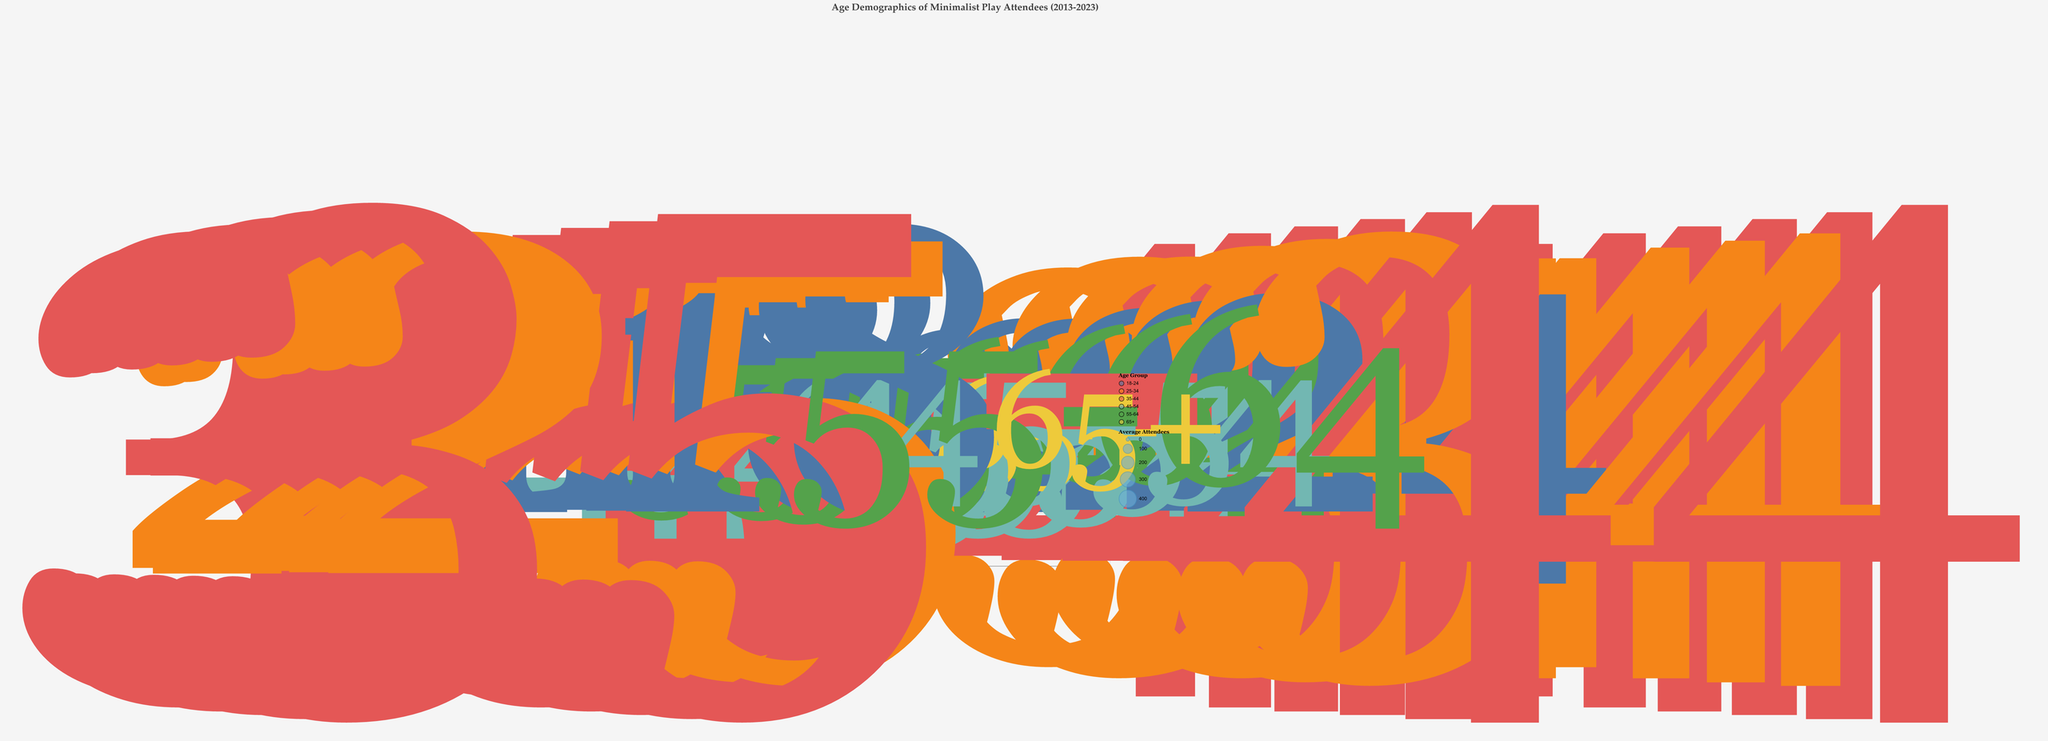What is the title of the chart? The title is displayed at the top of the chart in a larger font. The title reads, "Age Demographics of Minimalist Play Attendees (2013-2023)"
Answer: Age Demographics of Minimalist Play Attendees (2013-2023) What are the years represented on the x-axis? The x-axis marks the years, clearly visible along the horizontal axis. The years represented range from 2013 to 2023, with markers for individual years in-between.
Answer: 2013 to 2023 Which age group had the highest average attendees in 2023? Each bubble's size represents the average attendees, and each bubble's color represents an age group. The largest bubble in 2023, color-coded for the 35-44 age group, indicates this group had the highest average attendees.
Answer: 35-44 How did the average rating for the 55-64 age group change between 2013 and 2023? By observing the vertical position of the bubbles for the 55-64 age group in the years 2013 and 2023, it is clear that the rating increased. In 2013, the rating was at 4.0, and by 2023 it had risen to 4.5.
Answer: Increased from 4.0 to 4.5 What is the difference in average attendees between the 18-24 and 65+ age groups in 2023? Referring to the size of the bubbles for the 18-24 age group (250 attendees) and the 65+ age group (75 attendees) in 2023, subtracting the average attendees for 65+ from 18-24 yields a difference of 175.
Answer: 175 Which age group shows the highest average rating across the entire dataset? By observing the y-axis, which represents the average rating, the highest point is 5.4. Checking the bubble at this point shows it belongs to the 35-44 age group in the year 2023.
Answer: 35-44 Which year had the largest range of average ratings based on the bubbles' vertical span? Comparing the vertical span of the bubbles across the years, 2023 shows the largest range of ratings. The lowest rating is for the 65+ group at 4.0 and the highest rating is for the 35-44 group at 5.4, making the range 1.4.
Answer: 2023 Between which years did the 25-34 age group's average rating increase the most? Tracking the upward movement of the bubbles color-coded for the 25-34 age group shows an increase from a rating of 4.9 in 2017 to 5.0 in 2019, 5.1 in 2021, and 5.2 in 2023. The largest single-step increase is from 2017 to 2019 by 0.1.
Answer: 2017 to 2019 How does the set complexity score relate to the audience size over the years? By examining the tooltips, the set complexity scores tend to stay relatively stable and low, varying slightly around 1.2 to 1.6, regardless of the average attendees sizes. This lacks a clear pattern, suggesting set complexity does not directly correlate with audience size.
Answer: No clear pattern How do the average ratings of the youngest and oldest age groups compare overall? Reviewing the bubble positions for the youngest (18-24) and oldest (65+) age groups shows that the youngest consistently score higher over the years. For instance, the youngest range from 4.5 to 5.0, while the oldest range from 3.7 to 4.0.
Answer: 18-24 consistently higher 